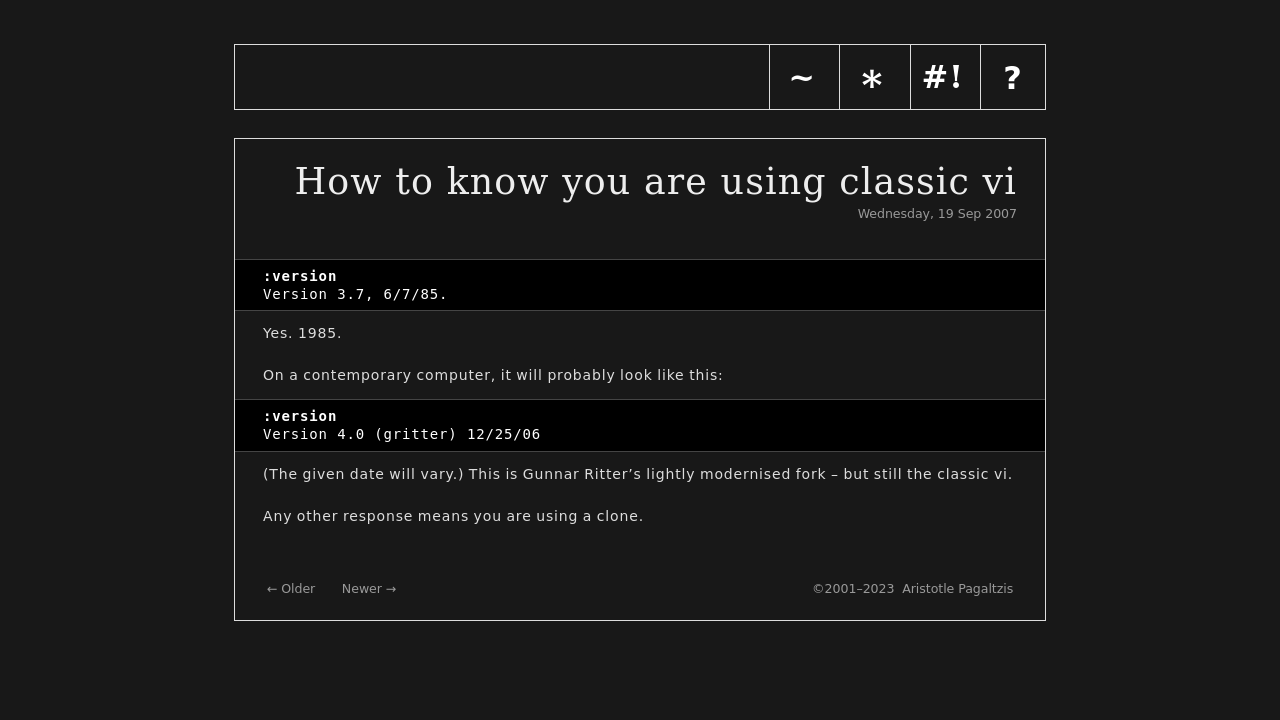How does the design of this website reflect its content about classic vi? The design of the website uses a minimalist and retro aesthetic that closely mirrors the simplicity and traditionalism of classic vi. The monochrome color scheme and classic typography reflect the old-school interface of vi editors. This stylistic choice not only pays homage to the terminal screens where vi originally operated but also emphasizes functionality over visual embellishment, mirroring vi's design philosophy. 